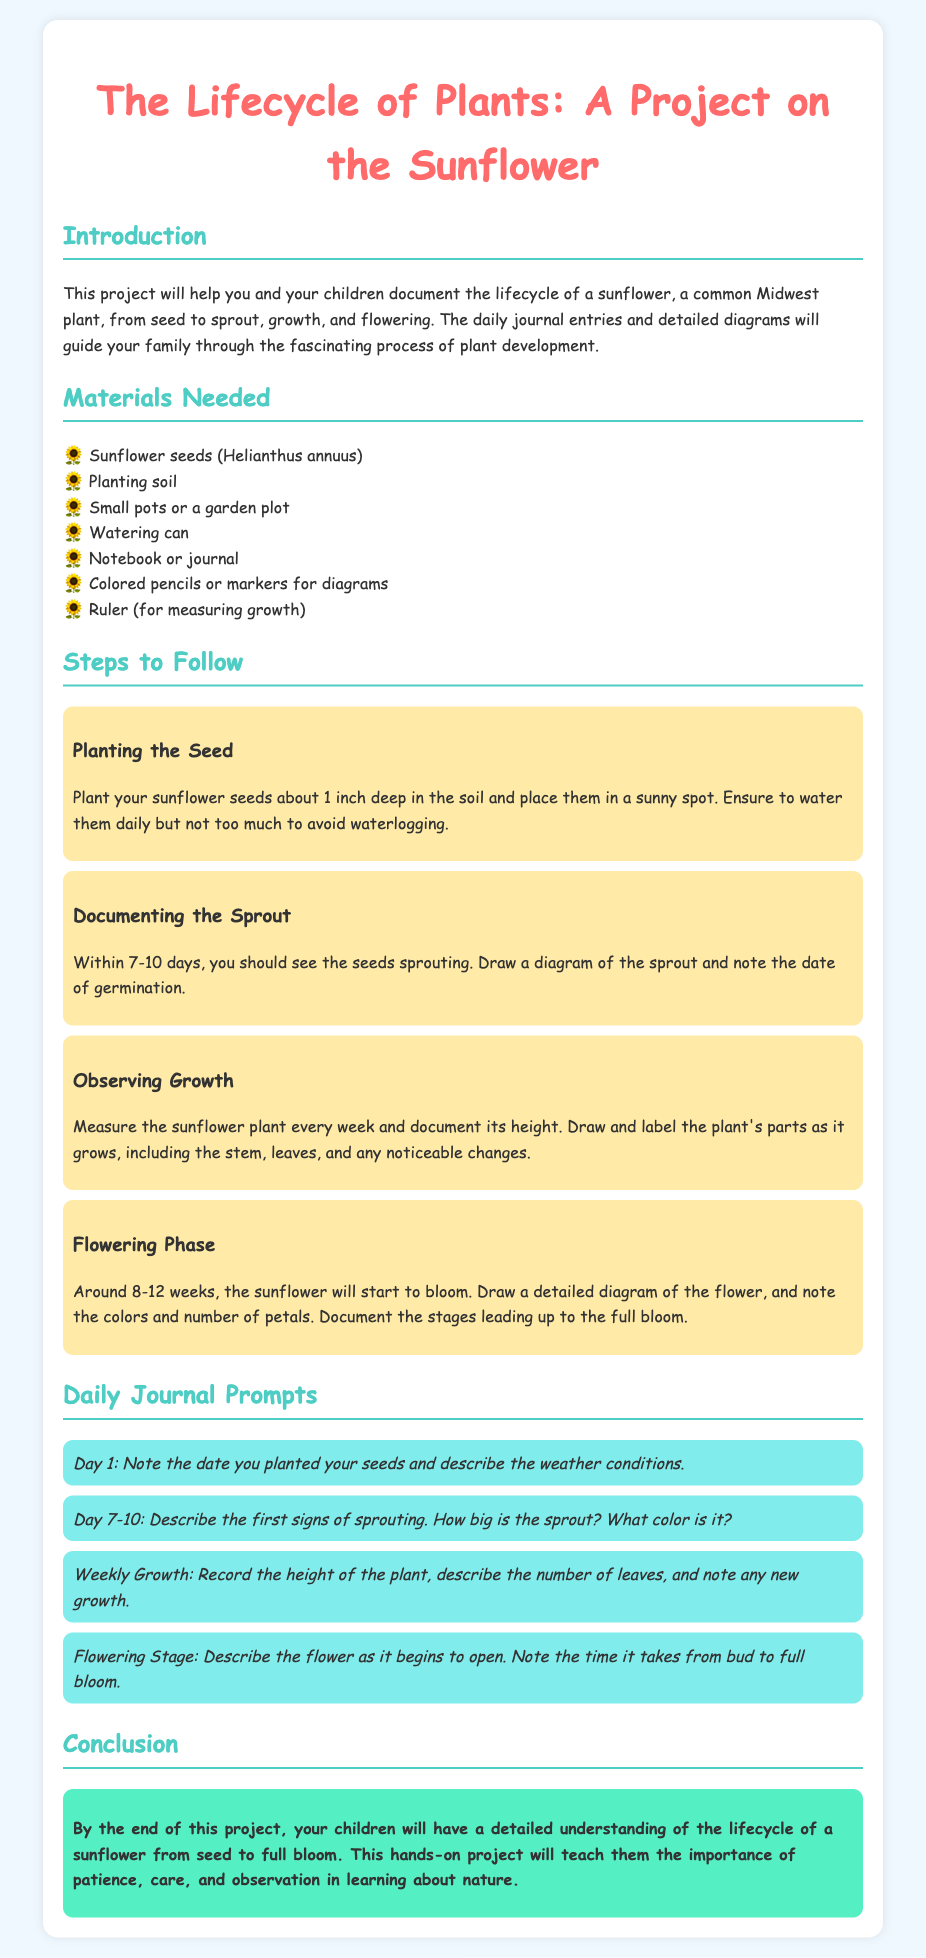What is the title of the project? The title of the project is mentioned in the header of the document.
Answer: The Lifecycle of Plants: A Project on the Sunflower How deep should sunflower seeds be planted? The document specifies the planting depth in the "Planting the Seed" section.
Answer: 1 inch What should be used to measure the growth of the sunflower? The "Materials Needed" section lists items to document the growth.
Answer: Ruler What day range should sprouting be expected? The expected range for sprouting is provided in the "Documenting the Sprout" section.
Answer: 7-10 days What color should the flower be documented as it blooms? The "Flowering Phase" section mentions describing the flower.
Answer: Colors What is the main purpose of this project? The introduction summarizes the project's purpose and educational goals.
Answer: Understanding the lifecycle of a sunflower What is one journal prompt for Day 1? The "Daily Journal Prompts" section provides specific prompts for documentation.
Answer: Note the date you planted your seeds and describe the weather conditions How many weeks does it take for the sunflower to bloom? The document gives a timeline for the flowering phase.
Answer: 8-12 weeks 